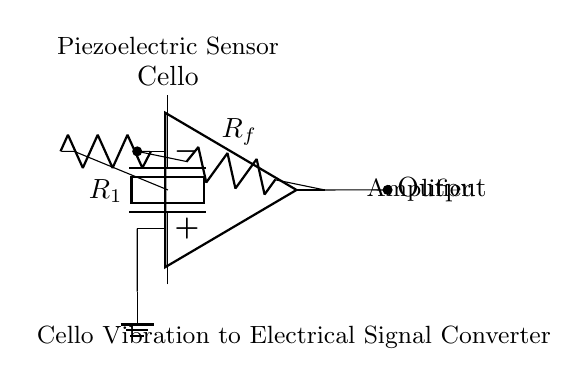What type of sensor is used in this circuit? The circuit diagram shows a piezoelectric sensor, which is specifically designed to convert mechanical vibrations from the cello into electrical signals. The label "Piezoelectric Sensor" above the component indicates this.
Answer: Piezoelectric sensor What component is connected to the positive terminal of the op amp? The positive terminal of the operational amplifier (op amp) is connected to the ground, indicated by the line going down to the ground node in the diagram. This connection is essential for setting a reference voltage for the amplifier.
Answer: Ground What is the function of the resistor labeled R_f? The resistor labeled R_f is a feedback resistor, which is used in amplifier circuits to control the gain of the op amp. It connects the output to the inverting input of the op amp, and its value helps determine how much of the output signal is fed back.
Answer: Feedback resistor How many resistors are present in this circuit? The circuit diagram features two resistors: R_1 and R_f, which are clearly labeled in the diagram. R_1 connects the piezoelectric sensor to the inverting input of the op amp, while R_f is connected directly to the output of the op amp.
Answer: Two Why is the output node indicated with a short line? The short line from the output of the op amp signifies that this point is where the electrical signal is available for further processing or recording. The arrow indicates the direction of the signal flow from the amplifier to the output.
Answer: Output signal What is the purpose of the piezoelectric sensor in this circuit? The piezoelectric sensor's purpose is to convert the mechanical vibrations produced by the cello into electrical signals. This conversion allows for the recording and amplification of the cello sound, making it a crucial component in the circuit configuration.
Answer: Convert vibrations to signals 